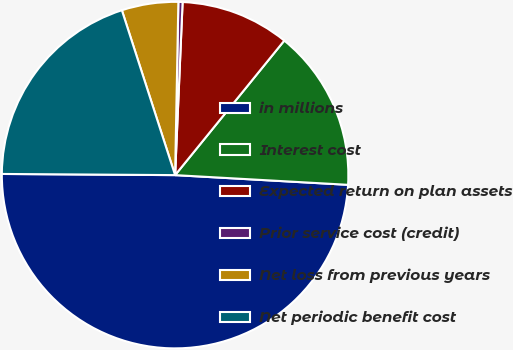Convert chart to OTSL. <chart><loc_0><loc_0><loc_500><loc_500><pie_chart><fcel>in millions<fcel>Interest cost<fcel>Expected return on plan assets<fcel>Prior service cost (credit)<fcel>Net loss from previous years<fcel>Net periodic benefit cost<nl><fcel>49.21%<fcel>15.04%<fcel>10.16%<fcel>0.39%<fcel>5.27%<fcel>19.92%<nl></chart> 